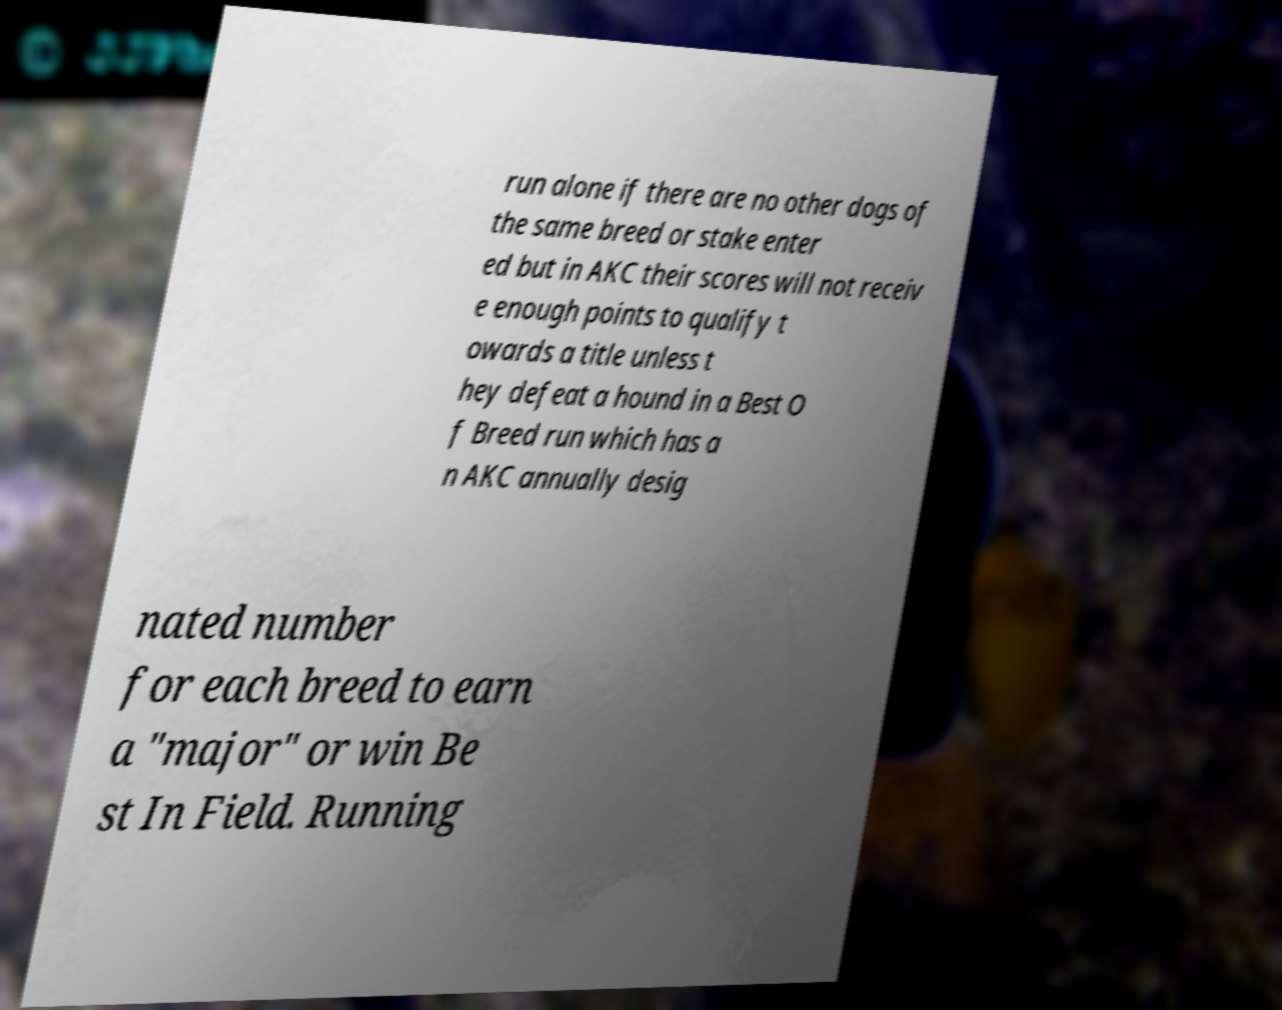Can you read and provide the text displayed in the image?This photo seems to have some interesting text. Can you extract and type it out for me? run alone if there are no other dogs of the same breed or stake enter ed but in AKC their scores will not receiv e enough points to qualify t owards a title unless t hey defeat a hound in a Best O f Breed run which has a n AKC annually desig nated number for each breed to earn a "major" or win Be st In Field. Running 